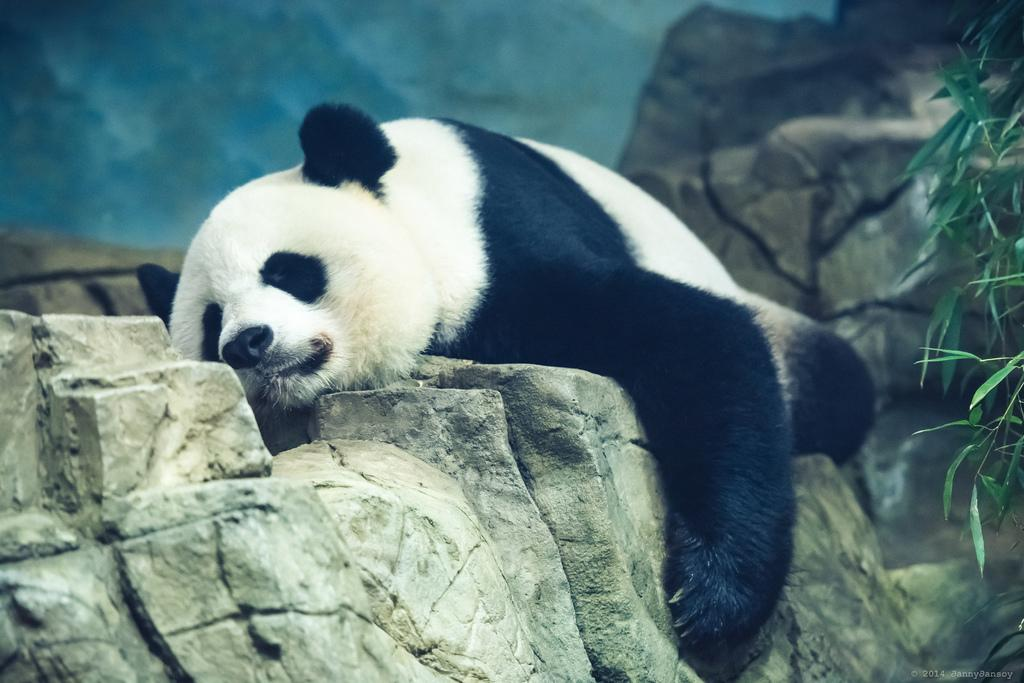What animal is the main subject of the image? There is a panda in the image. What is the panda doing in the image? The panda is laying on a rock. What can be seen on the right side of the panda? There is a plant on the right side of the panda. What language is the panda speaking in the image? Pandas do not speak human languages, and there is no indication in the image that the panda is communicating verbally. 